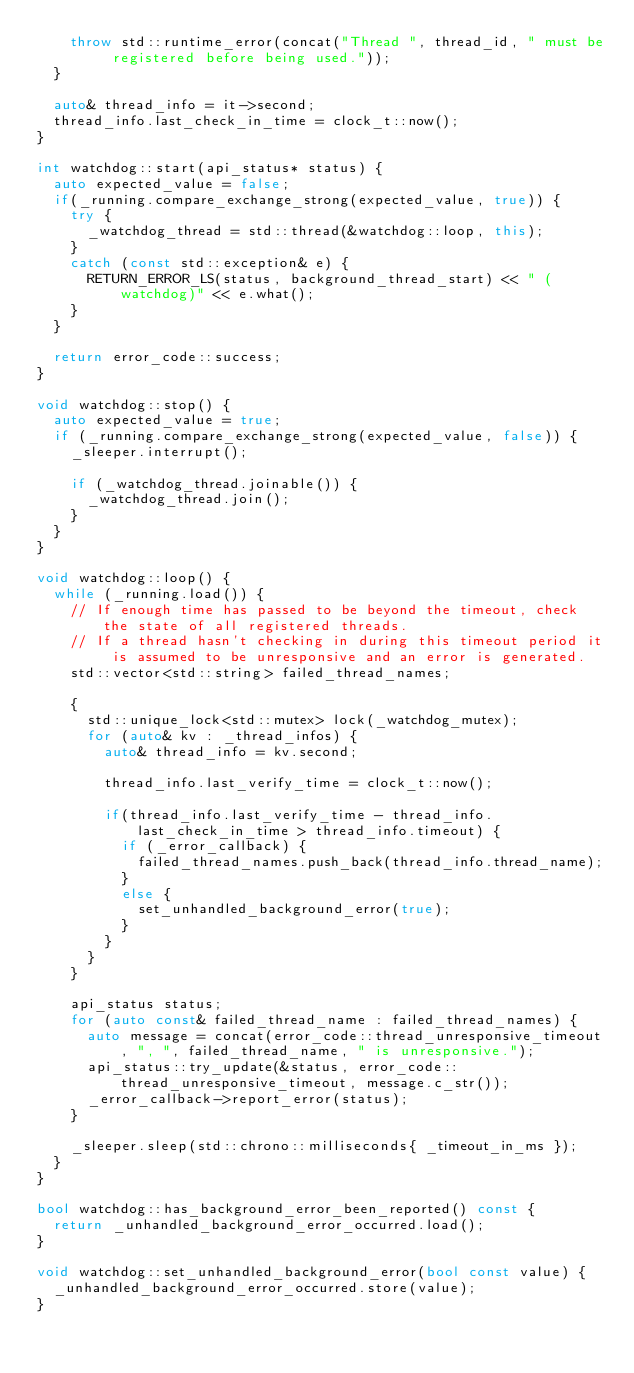Convert code to text. <code><loc_0><loc_0><loc_500><loc_500><_C++_>    throw std::runtime_error(concat("Thread ", thread_id, " must be registered before being used."));
  }

  auto& thread_info = it->second;
  thread_info.last_check_in_time = clock_t::now();
}

int watchdog::start(api_status* status) {
  auto expected_value = false;
  if(_running.compare_exchange_strong(expected_value, true)) {
    try {
      _watchdog_thread = std::thread(&watchdog::loop, this);
    }
    catch (const std::exception& e) {
      RETURN_ERROR_LS(status, background_thread_start) << " (watchdog)" << e.what();
    }
  }

  return error_code::success;
}

void watchdog::stop() {
  auto expected_value = true;
  if (_running.compare_exchange_strong(expected_value, false)) {
    _sleeper.interrupt();

    if (_watchdog_thread.joinable()) {
      _watchdog_thread.join();
    }
  }
}

void watchdog::loop() {
  while (_running.load()) {
    // If enough time has passed to be beyond the timeout, check the state of all registered threads.
    // If a thread hasn't checking in during this timeout period it is assumed to be unresponsive and an error is generated.
    std::vector<std::string> failed_thread_names;

    {
      std::unique_lock<std::mutex> lock(_watchdog_mutex);
      for (auto& kv : _thread_infos) {
        auto& thread_info = kv.second;

        thread_info.last_verify_time = clock_t::now();

        if(thread_info.last_verify_time - thread_info.last_check_in_time > thread_info.timeout) {
          if (_error_callback) {
            failed_thread_names.push_back(thread_info.thread_name);
          }
          else {
            set_unhandled_background_error(true);
          }
        }
      }
    }

    api_status status;
    for (auto const& failed_thread_name : failed_thread_names) {
      auto message = concat(error_code::thread_unresponsive_timeout, ", ", failed_thread_name, " is unresponsive.");
      api_status::try_update(&status, error_code::thread_unresponsive_timeout, message.c_str());
      _error_callback->report_error(status);
    }

    _sleeper.sleep(std::chrono::milliseconds{ _timeout_in_ms });
  }
}

bool watchdog::has_background_error_been_reported() const {
  return _unhandled_background_error_occurred.load();
}

void watchdog::set_unhandled_background_error(bool const value) {
  _unhandled_background_error_occurred.store(value);
}
</code> 